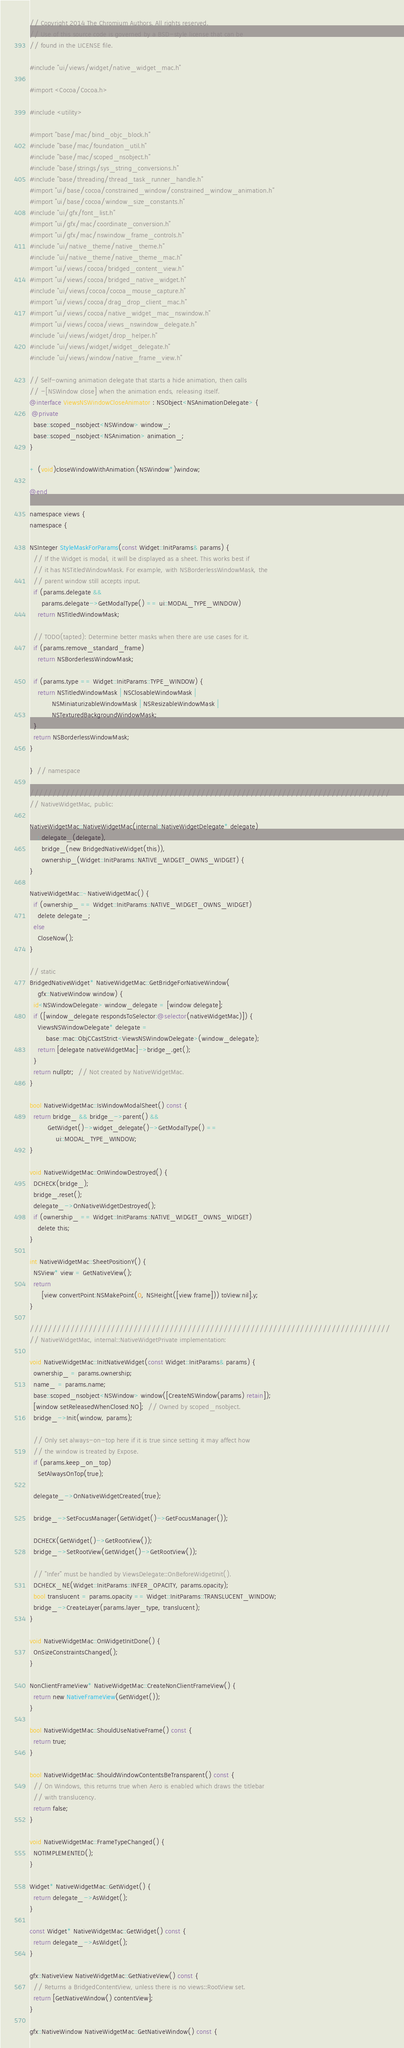Convert code to text. <code><loc_0><loc_0><loc_500><loc_500><_ObjectiveC_>// Copyright 2014 The Chromium Authors. All rights reserved.
// Use of this source code is governed by a BSD-style license that can be
// found in the LICENSE file.

#include "ui/views/widget/native_widget_mac.h"

#import <Cocoa/Cocoa.h>

#include <utility>

#import "base/mac/bind_objc_block.h"
#include "base/mac/foundation_util.h"
#include "base/mac/scoped_nsobject.h"
#include "base/strings/sys_string_conversions.h"
#include "base/threading/thread_task_runner_handle.h"
#import "ui/base/cocoa/constrained_window/constrained_window_animation.h"
#import "ui/base/cocoa/window_size_constants.h"
#include "ui/gfx/font_list.h"
#import "ui/gfx/mac/coordinate_conversion.h"
#import "ui/gfx/mac/nswindow_frame_controls.h"
#include "ui/native_theme/native_theme.h"
#include "ui/native_theme/native_theme_mac.h"
#import "ui/views/cocoa/bridged_content_view.h"
#import "ui/views/cocoa/bridged_native_widget.h"
#include "ui/views/cocoa/cocoa_mouse_capture.h"
#import "ui/views/cocoa/drag_drop_client_mac.h"
#import "ui/views/cocoa/native_widget_mac_nswindow.h"
#import "ui/views/cocoa/views_nswindow_delegate.h"
#include "ui/views/widget/drop_helper.h"
#include "ui/views/widget/widget_delegate.h"
#include "ui/views/window/native_frame_view.h"

// Self-owning animation delegate that starts a hide animation, then calls
// -[NSWindow close] when the animation ends, releasing itself.
@interface ViewsNSWindowCloseAnimator : NSObject<NSAnimationDelegate> {
 @private
  base::scoped_nsobject<NSWindow> window_;
  base::scoped_nsobject<NSAnimation> animation_;
}

+ (void)closeWindowWithAnimation:(NSWindow*)window;

@end

namespace views {
namespace {

NSInteger StyleMaskForParams(const Widget::InitParams& params) {
  // If the Widget is modal, it will be displayed as a sheet. This works best if
  // it has NSTitledWindowMask. For example, with NSBorderlessWindowMask, the
  // parent window still accepts input.
  if (params.delegate &&
      params.delegate->GetModalType() == ui::MODAL_TYPE_WINDOW)
    return NSTitledWindowMask;

  // TODO(tapted): Determine better masks when there are use cases for it.
  if (params.remove_standard_frame)
    return NSBorderlessWindowMask;

  if (params.type == Widget::InitParams::TYPE_WINDOW) {
    return NSTitledWindowMask | NSClosableWindowMask |
           NSMiniaturizableWindowMask | NSResizableWindowMask |
           NSTexturedBackgroundWindowMask;
  }
  return NSBorderlessWindowMask;
}

}  // namespace

////////////////////////////////////////////////////////////////////////////////
// NativeWidgetMac, public:

NativeWidgetMac::NativeWidgetMac(internal::NativeWidgetDelegate* delegate)
    : delegate_(delegate),
      bridge_(new BridgedNativeWidget(this)),
      ownership_(Widget::InitParams::NATIVE_WIDGET_OWNS_WIDGET) {
}

NativeWidgetMac::~NativeWidgetMac() {
  if (ownership_ == Widget::InitParams::NATIVE_WIDGET_OWNS_WIDGET)
    delete delegate_;
  else
    CloseNow();
}

// static
BridgedNativeWidget* NativeWidgetMac::GetBridgeForNativeWindow(
    gfx::NativeWindow window) {
  id<NSWindowDelegate> window_delegate = [window delegate];
  if ([window_delegate respondsToSelector:@selector(nativeWidgetMac)]) {
    ViewsNSWindowDelegate* delegate =
        base::mac::ObjCCastStrict<ViewsNSWindowDelegate>(window_delegate);
    return [delegate nativeWidgetMac]->bridge_.get();
  }
  return nullptr;  // Not created by NativeWidgetMac.
}

bool NativeWidgetMac::IsWindowModalSheet() const {
  return bridge_ && bridge_->parent() &&
         GetWidget()->widget_delegate()->GetModalType() ==
             ui::MODAL_TYPE_WINDOW;
}

void NativeWidgetMac::OnWindowDestroyed() {
  DCHECK(bridge_);
  bridge_.reset();
  delegate_->OnNativeWidgetDestroyed();
  if (ownership_ == Widget::InitParams::NATIVE_WIDGET_OWNS_WIDGET)
    delete this;
}

int NativeWidgetMac::SheetPositionY() {
  NSView* view = GetNativeView();
  return
      [view convertPoint:NSMakePoint(0, NSHeight([view frame])) toView:nil].y;
}

////////////////////////////////////////////////////////////////////////////////
// NativeWidgetMac, internal::NativeWidgetPrivate implementation:

void NativeWidgetMac::InitNativeWidget(const Widget::InitParams& params) {
  ownership_ = params.ownership;
  name_ = params.name;
  base::scoped_nsobject<NSWindow> window([CreateNSWindow(params) retain]);
  [window setReleasedWhenClosed:NO];  // Owned by scoped_nsobject.
  bridge_->Init(window, params);

  // Only set always-on-top here if it is true since setting it may affect how
  // the window is treated by Expose.
  if (params.keep_on_top)
    SetAlwaysOnTop(true);

  delegate_->OnNativeWidgetCreated(true);

  bridge_->SetFocusManager(GetWidget()->GetFocusManager());

  DCHECK(GetWidget()->GetRootView());
  bridge_->SetRootView(GetWidget()->GetRootView());

  // "Infer" must be handled by ViewsDelegate::OnBeforeWidgetInit().
  DCHECK_NE(Widget::InitParams::INFER_OPACITY, params.opacity);
  bool translucent = params.opacity == Widget::InitParams::TRANSLUCENT_WINDOW;
  bridge_->CreateLayer(params.layer_type, translucent);
}

void NativeWidgetMac::OnWidgetInitDone() {
  OnSizeConstraintsChanged();
}

NonClientFrameView* NativeWidgetMac::CreateNonClientFrameView() {
  return new NativeFrameView(GetWidget());
}

bool NativeWidgetMac::ShouldUseNativeFrame() const {
  return true;
}

bool NativeWidgetMac::ShouldWindowContentsBeTransparent() const {
  // On Windows, this returns true when Aero is enabled which draws the titlebar
  // with translucency.
  return false;
}

void NativeWidgetMac::FrameTypeChanged() {
  NOTIMPLEMENTED();
}

Widget* NativeWidgetMac::GetWidget() {
  return delegate_->AsWidget();
}

const Widget* NativeWidgetMac::GetWidget() const {
  return delegate_->AsWidget();
}

gfx::NativeView NativeWidgetMac::GetNativeView() const {
  // Returns a BridgedContentView, unless there is no views::RootView set.
  return [GetNativeWindow() contentView];
}

gfx::NativeWindow NativeWidgetMac::GetNativeWindow() const {</code> 